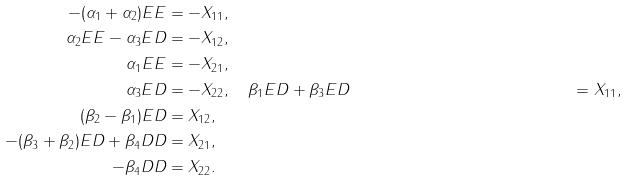Convert formula to latex. <formula><loc_0><loc_0><loc_500><loc_500>- ( \alpha _ { 1 } + \alpha _ { 2 } ) E E & = - X _ { 1 1 } , \quad \\ \alpha _ { 2 } E E - \alpha _ { 3 } E D & = - X _ { 1 2 } , \quad \\ \alpha _ { 1 } E E & = - X _ { 2 1 } , \quad \\ \alpha _ { 3 } E D & = - X _ { 2 2 } , \quad \beta _ { 1 } E D + \beta _ { 3 } E D & = X _ { 1 1 } , \\ ( \beta _ { 2 } - \beta _ { 1 } ) E D & = X _ { 1 2 } , \\ - ( \beta _ { 3 } + \beta _ { 2 } ) E D + \beta _ { 4 } D D & = X _ { 2 1 } , \\ - \beta _ { 4 } D D & = X _ { 2 2 } .</formula> 